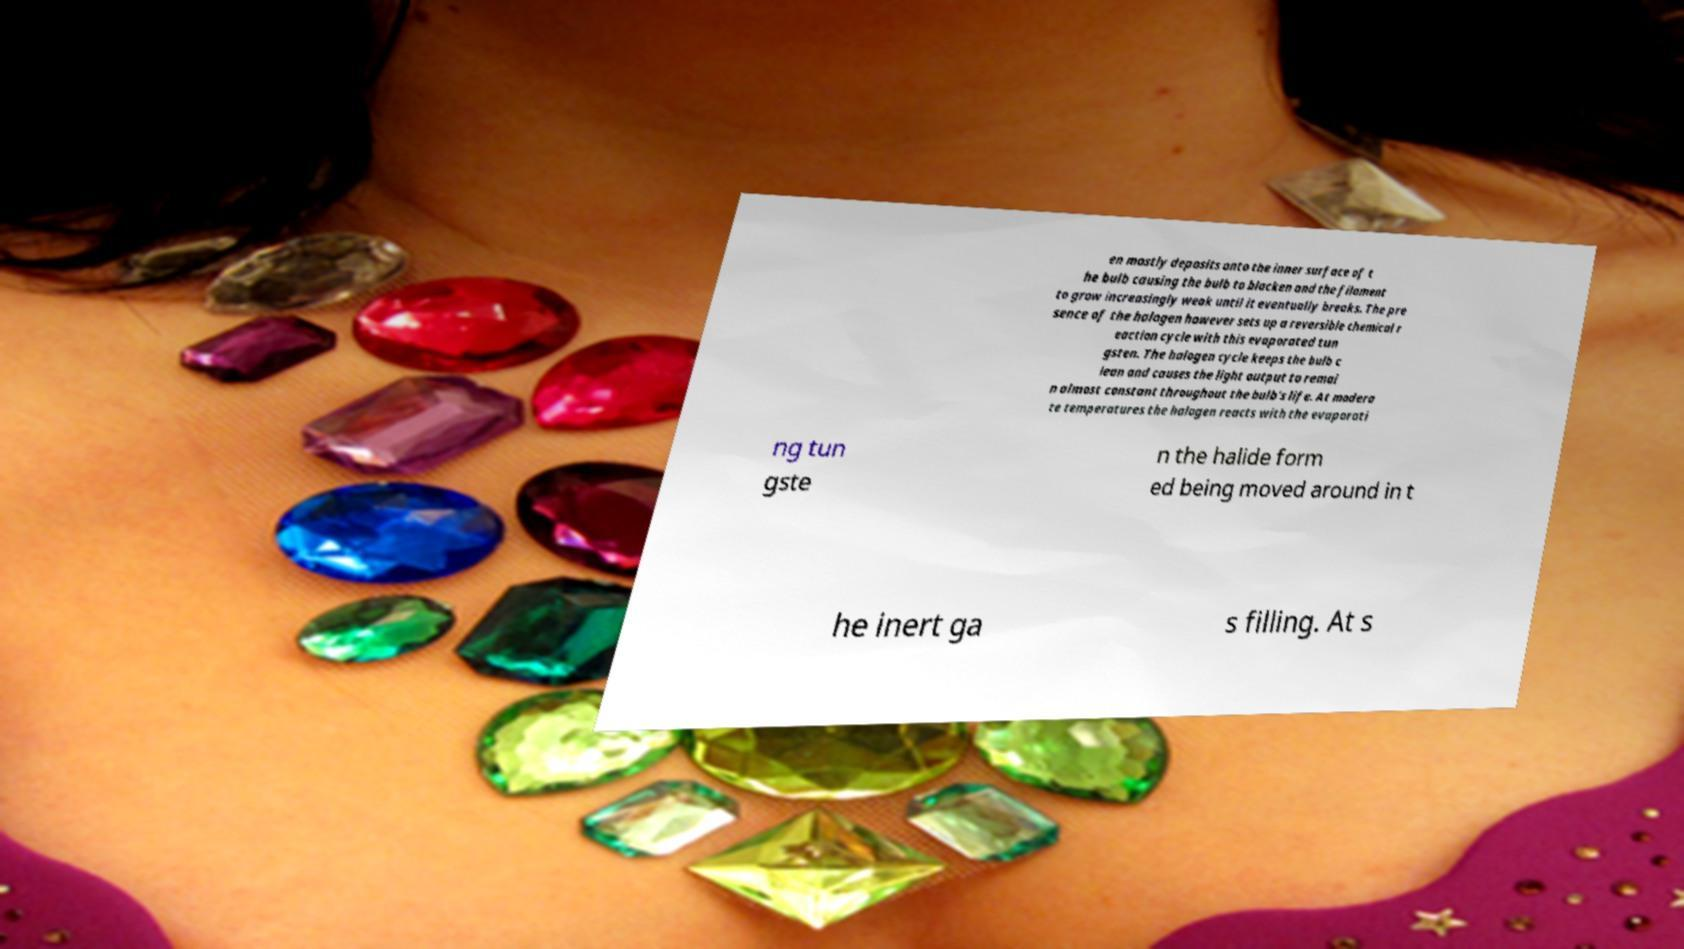Can you accurately transcribe the text from the provided image for me? en mostly deposits onto the inner surface of t he bulb causing the bulb to blacken and the filament to grow increasingly weak until it eventually breaks. The pre sence of the halogen however sets up a reversible chemical r eaction cycle with this evaporated tun gsten. The halogen cycle keeps the bulb c lean and causes the light output to remai n almost constant throughout the bulb's life. At modera te temperatures the halogen reacts with the evaporati ng tun gste n the halide form ed being moved around in t he inert ga s filling. At s 